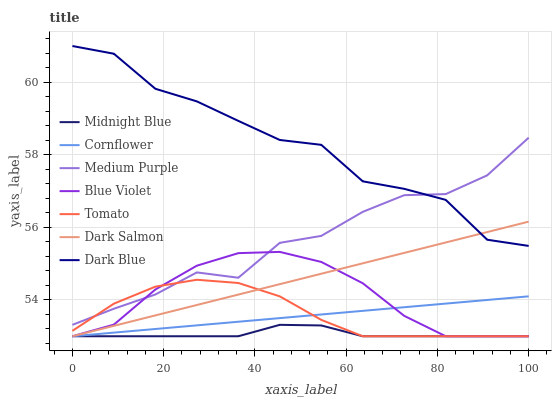Does Midnight Blue have the minimum area under the curve?
Answer yes or no. Yes. Does Dark Blue have the maximum area under the curve?
Answer yes or no. Yes. Does Cornflower have the minimum area under the curve?
Answer yes or no. No. Does Cornflower have the maximum area under the curve?
Answer yes or no. No. Is Dark Salmon the smoothest?
Answer yes or no. Yes. Is Dark Blue the roughest?
Answer yes or no. Yes. Is Cornflower the smoothest?
Answer yes or no. No. Is Cornflower the roughest?
Answer yes or no. No. Does Tomato have the lowest value?
Answer yes or no. Yes. Does Medium Purple have the lowest value?
Answer yes or no. No. Does Dark Blue have the highest value?
Answer yes or no. Yes. Does Cornflower have the highest value?
Answer yes or no. No. Is Midnight Blue less than Medium Purple?
Answer yes or no. Yes. Is Dark Blue greater than Tomato?
Answer yes or no. Yes. Does Midnight Blue intersect Blue Violet?
Answer yes or no. Yes. Is Midnight Blue less than Blue Violet?
Answer yes or no. No. Is Midnight Blue greater than Blue Violet?
Answer yes or no. No. Does Midnight Blue intersect Medium Purple?
Answer yes or no. No. 